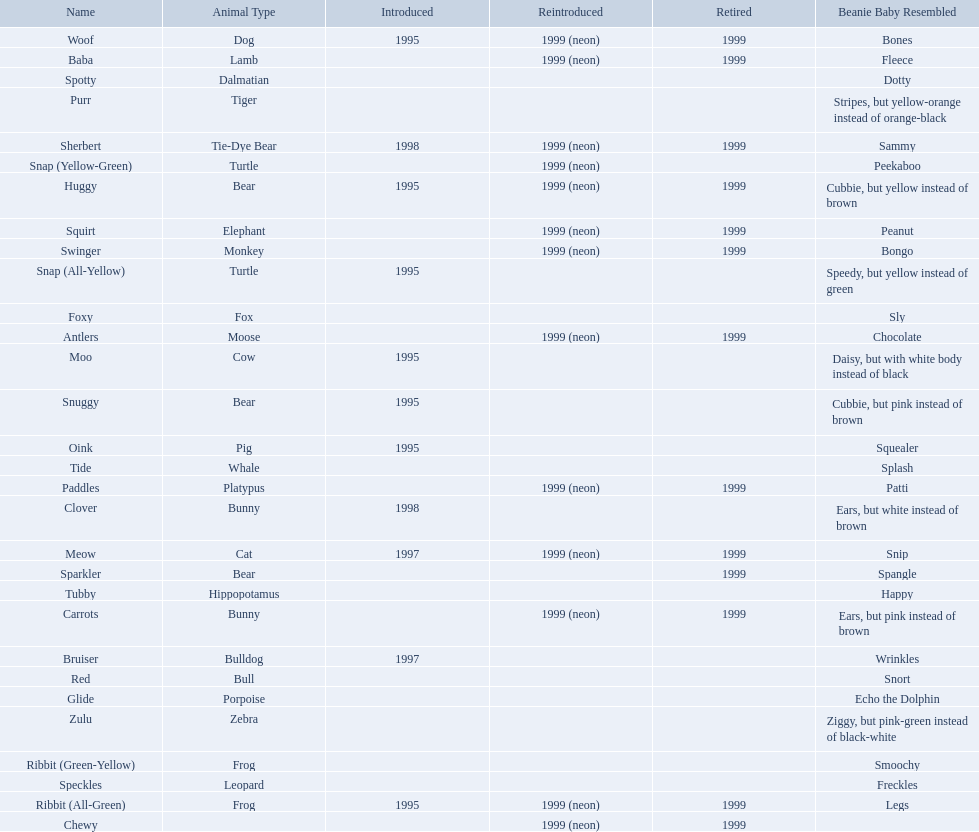What are the types of pillow pal animals? Antlers, Moose, Lamb, Bulldog, Bunny, , Bunny, Fox, Porpoise, Bear, Cat, Cow, Pig, Platypus, Tiger, Bull, Frog, Frog, Tie-Dye Bear, Turtle, Turtle, Bear, Bear, Leopard, Dalmatian, Elephant, Monkey, Whale, Hippopotamus, Dog, Zebra. Of those, which is a dalmatian? Dalmatian. What is the name of the dalmatian? Spotty. 